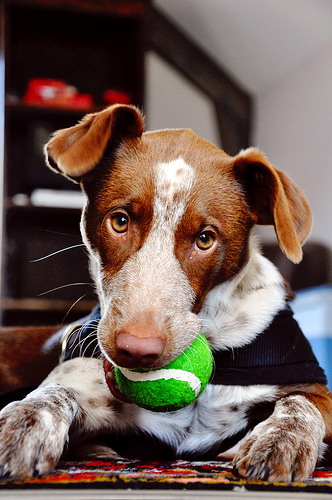<image>
Is the dog behind the ball? Yes. From this viewpoint, the dog is positioned behind the ball, with the ball partially or fully occluding the dog. 